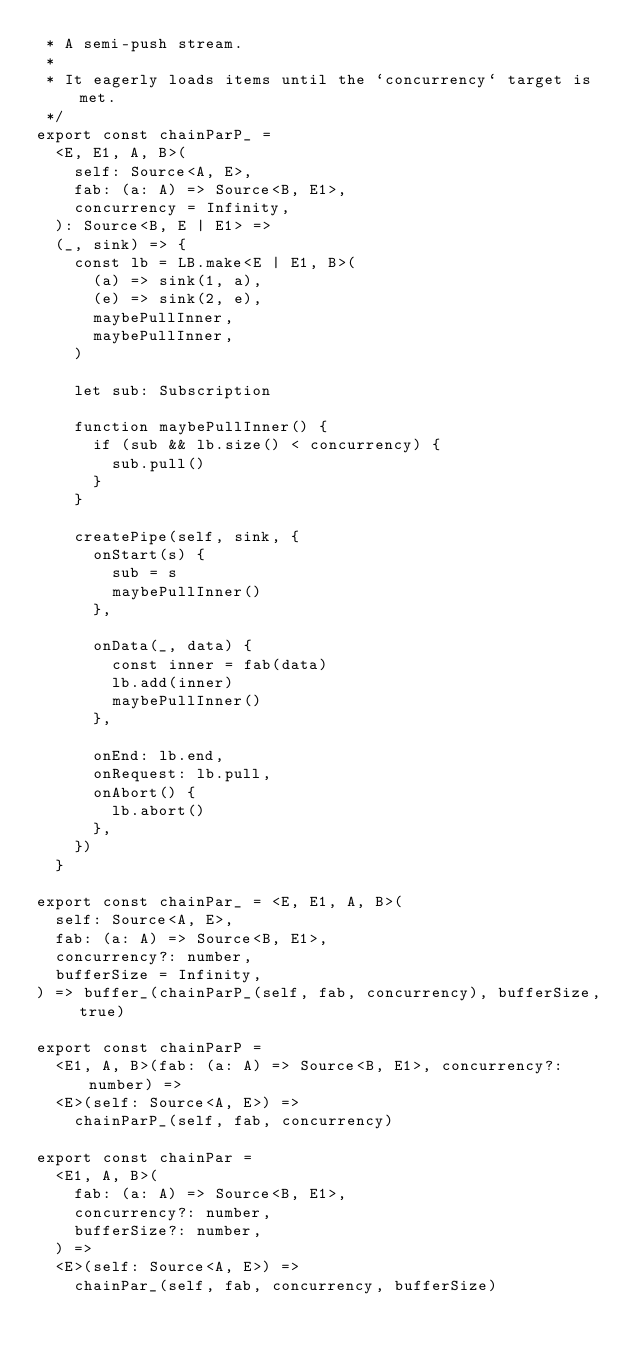<code> <loc_0><loc_0><loc_500><loc_500><_TypeScript_> * A semi-push stream.
 *
 * It eagerly loads items until the `concurrency` target is met.
 */
export const chainParP_ =
  <E, E1, A, B>(
    self: Source<A, E>,
    fab: (a: A) => Source<B, E1>,
    concurrency = Infinity,
  ): Source<B, E | E1> =>
  (_, sink) => {
    const lb = LB.make<E | E1, B>(
      (a) => sink(1, a),
      (e) => sink(2, e),
      maybePullInner,
      maybePullInner,
    )

    let sub: Subscription

    function maybePullInner() {
      if (sub && lb.size() < concurrency) {
        sub.pull()
      }
    }

    createPipe(self, sink, {
      onStart(s) {
        sub = s
        maybePullInner()
      },

      onData(_, data) {
        const inner = fab(data)
        lb.add(inner)
        maybePullInner()
      },

      onEnd: lb.end,
      onRequest: lb.pull,
      onAbort() {
        lb.abort()
      },
    })
  }

export const chainPar_ = <E, E1, A, B>(
  self: Source<A, E>,
  fab: (a: A) => Source<B, E1>,
  concurrency?: number,
  bufferSize = Infinity,
) => buffer_(chainParP_(self, fab, concurrency), bufferSize, true)

export const chainParP =
  <E1, A, B>(fab: (a: A) => Source<B, E1>, concurrency?: number) =>
  <E>(self: Source<A, E>) =>
    chainParP_(self, fab, concurrency)

export const chainPar =
  <E1, A, B>(
    fab: (a: A) => Source<B, E1>,
    concurrency?: number,
    bufferSize?: number,
  ) =>
  <E>(self: Source<A, E>) =>
    chainPar_(self, fab, concurrency, bufferSize)
</code> 